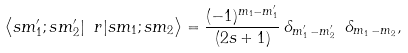<formula> <loc_0><loc_0><loc_500><loc_500>\left \langle s m _ { 1 } ^ { \prime } ; s m _ { 2 } ^ { \prime } | \ r | s m _ { 1 } ; s m _ { 2 } \right \rangle = \frac { ( - 1 ) ^ { m _ { 1 } - m _ { 1 } ^ { \prime } } } { ( 2 s + 1 ) } \, \delta _ { m _ { 1 } ^ { \prime } \, - m _ { 2 } ^ { \prime } } \ \delta _ { m _ { 1 } \, - m _ { 2 } } ,</formula> 